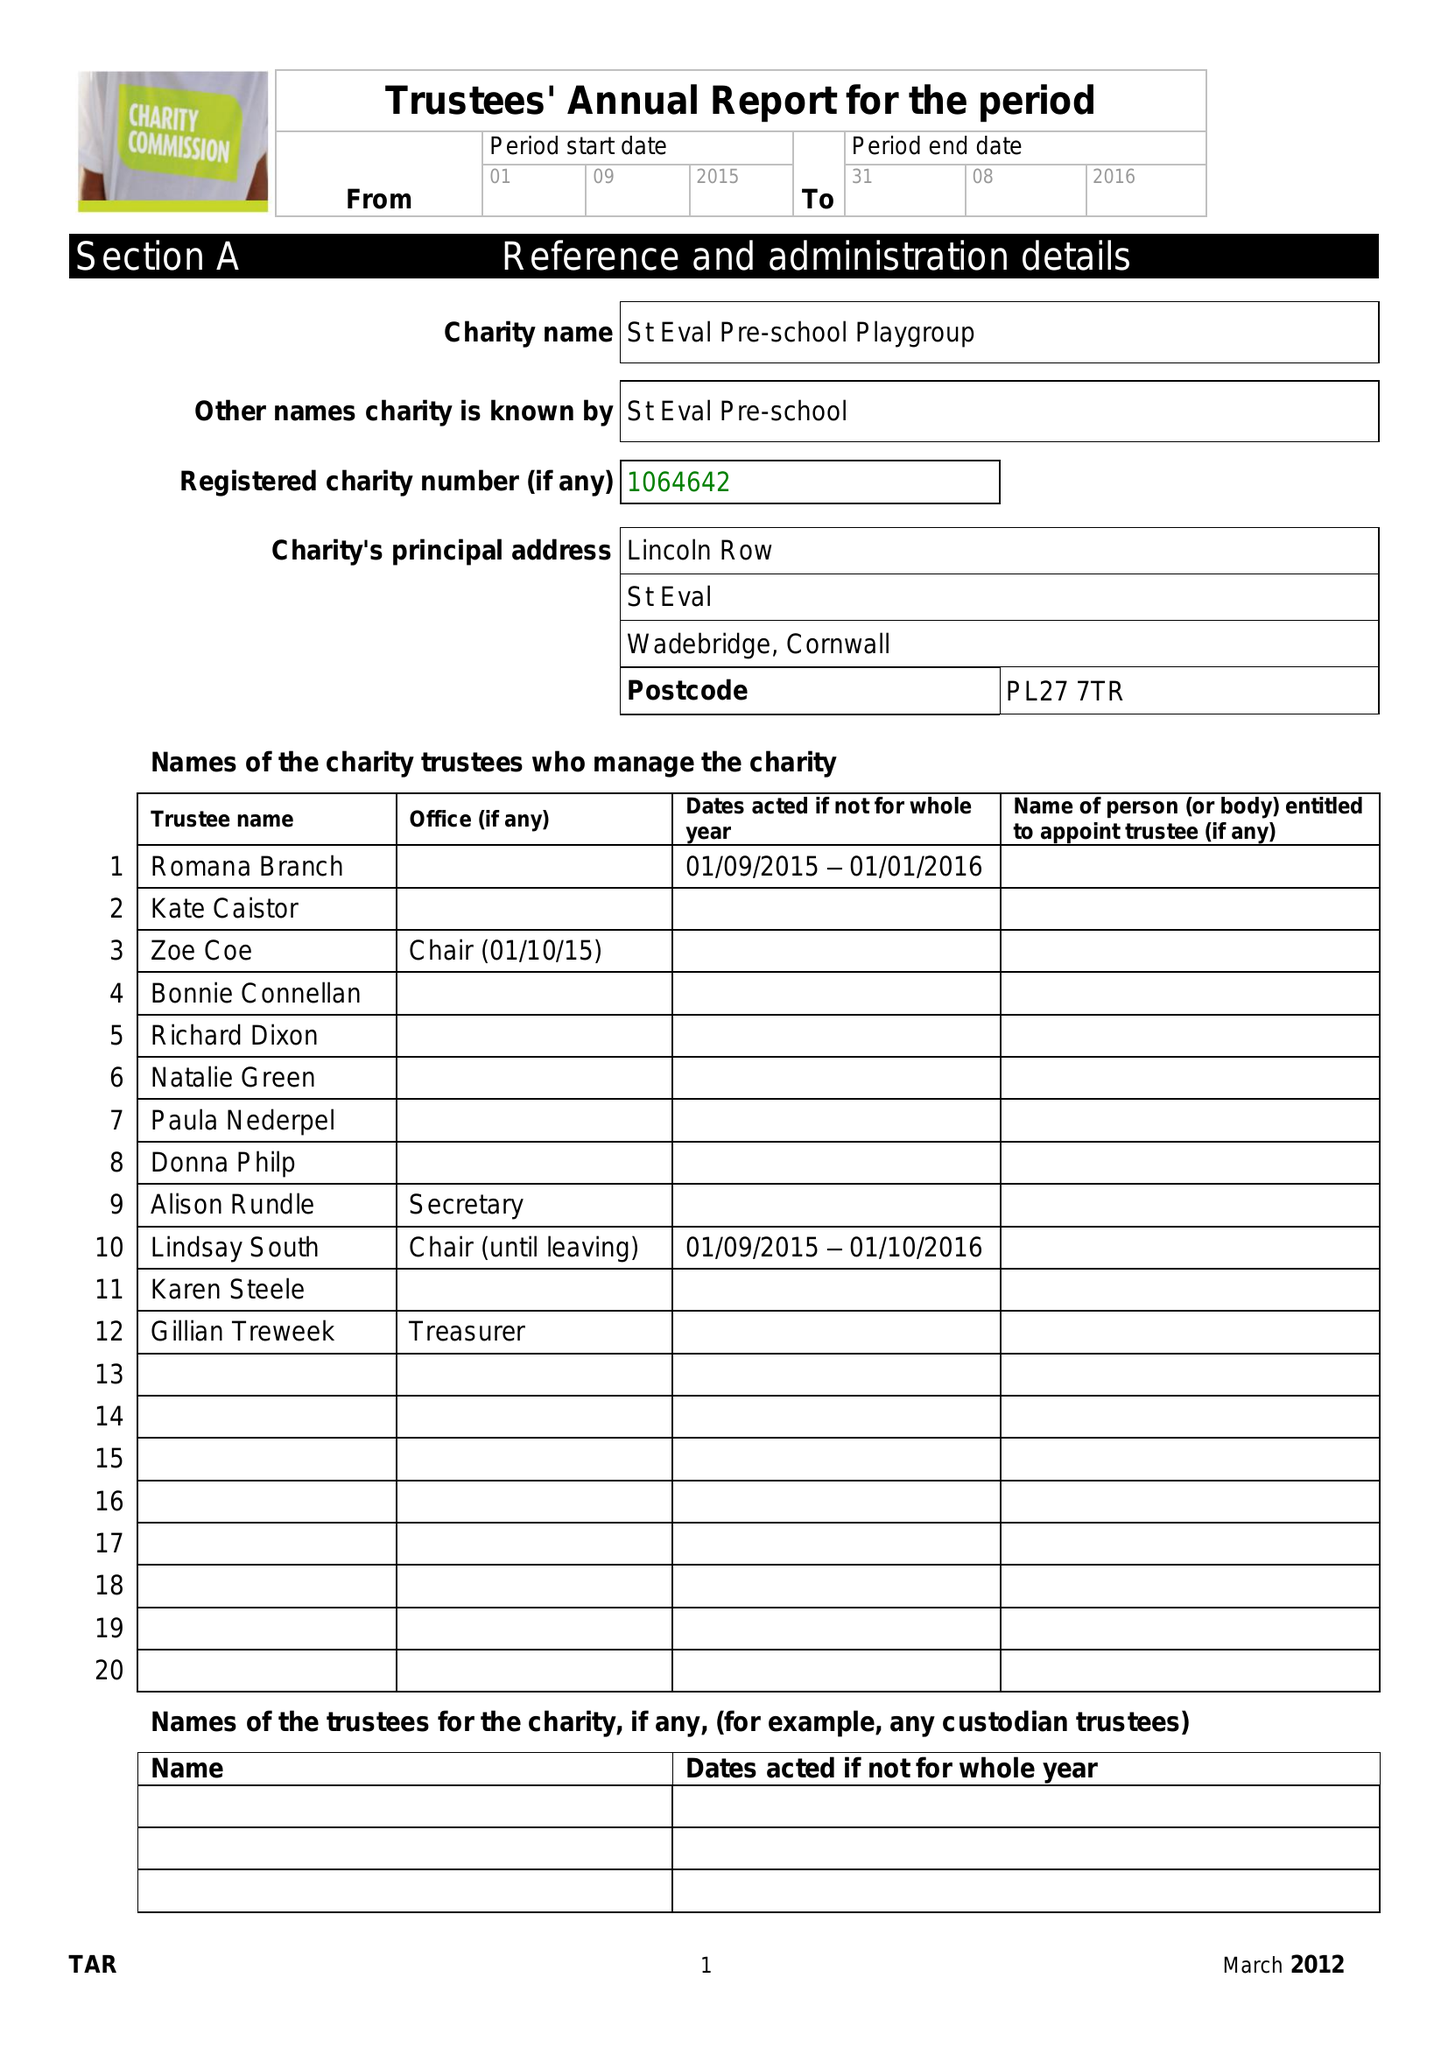What is the value for the charity_name?
Answer the question using a single word or phrase. St Eval Pre-School Playgroup 